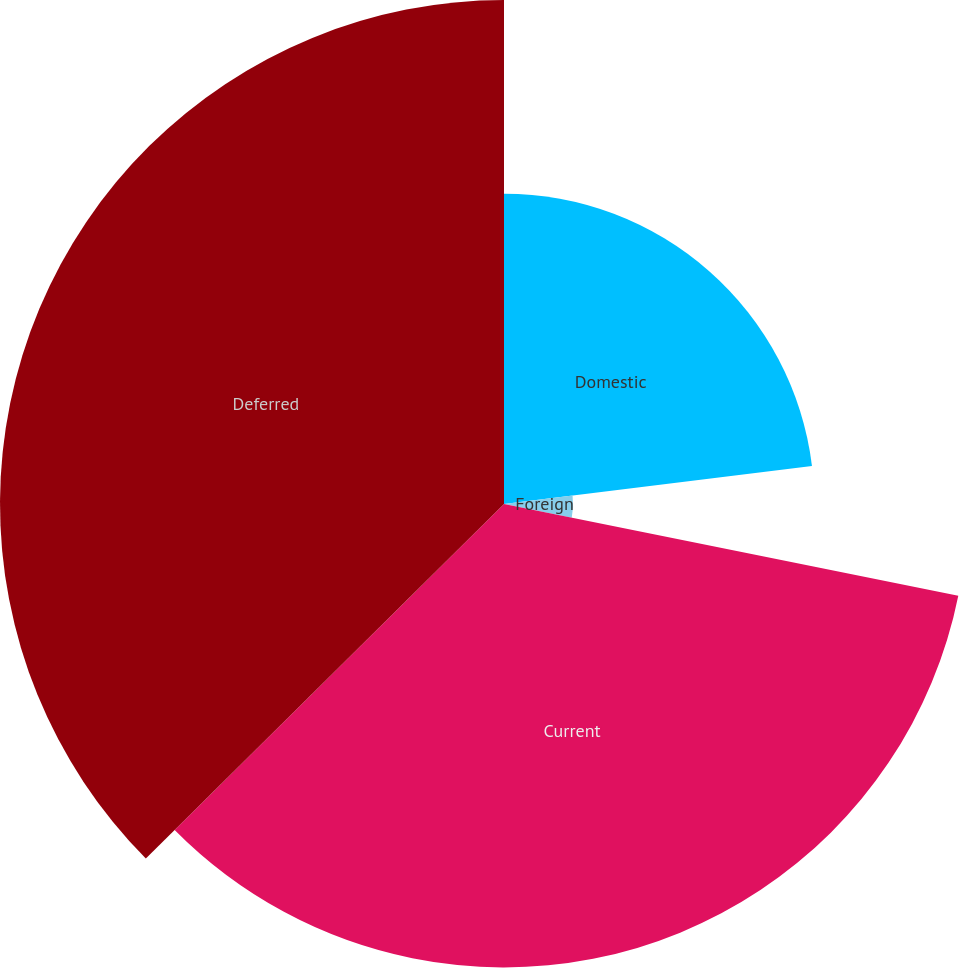Convert chart. <chart><loc_0><loc_0><loc_500><loc_500><pie_chart><fcel>Domestic<fcel>Foreign<fcel>Current<fcel>Deferred<nl><fcel>23.04%<fcel>5.13%<fcel>34.41%<fcel>37.42%<nl></chart> 